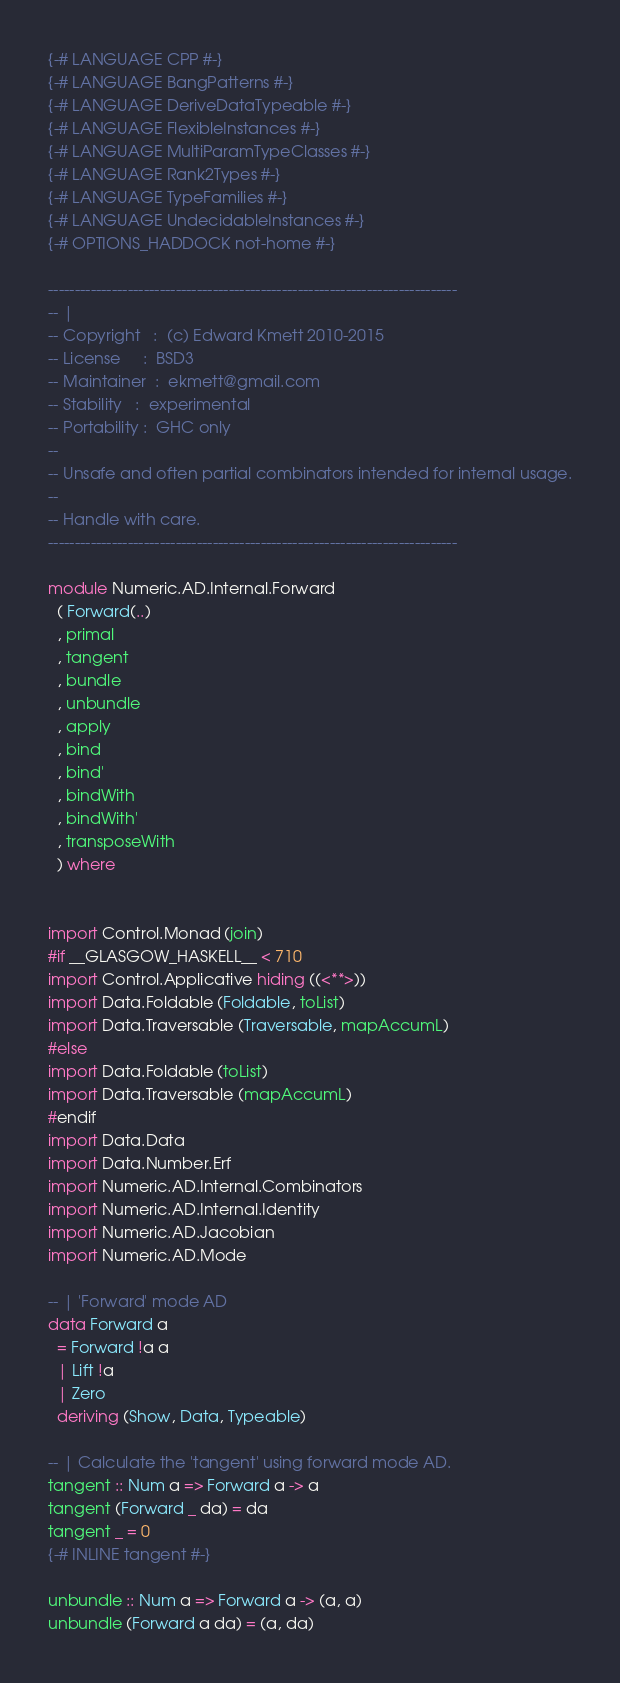<code> <loc_0><loc_0><loc_500><loc_500><_Haskell_>{-# LANGUAGE CPP #-}
{-# LANGUAGE BangPatterns #-}
{-# LANGUAGE DeriveDataTypeable #-}
{-# LANGUAGE FlexibleInstances #-}
{-# LANGUAGE MultiParamTypeClasses #-}
{-# LANGUAGE Rank2Types #-}
{-# LANGUAGE TypeFamilies #-}
{-# LANGUAGE UndecidableInstances #-}
{-# OPTIONS_HADDOCK not-home #-}

-----------------------------------------------------------------------------
-- |
-- Copyright   :  (c) Edward Kmett 2010-2015
-- License     :  BSD3
-- Maintainer  :  ekmett@gmail.com
-- Stability   :  experimental
-- Portability :  GHC only
--
-- Unsafe and often partial combinators intended for internal usage.
--
-- Handle with care.
-----------------------------------------------------------------------------

module Numeric.AD.Internal.Forward
  ( Forward(..)
  , primal
  , tangent
  , bundle
  , unbundle
  , apply
  , bind
  , bind'
  , bindWith
  , bindWith'
  , transposeWith
  ) where


import Control.Monad (join)
#if __GLASGOW_HASKELL__ < 710
import Control.Applicative hiding ((<**>))
import Data.Foldable (Foldable, toList)
import Data.Traversable (Traversable, mapAccumL)
#else
import Data.Foldable (toList)
import Data.Traversable (mapAccumL)
#endif
import Data.Data
import Data.Number.Erf
import Numeric.AD.Internal.Combinators
import Numeric.AD.Internal.Identity
import Numeric.AD.Jacobian
import Numeric.AD.Mode

-- | 'Forward' mode AD
data Forward a
  = Forward !a a
  | Lift !a
  | Zero
  deriving (Show, Data, Typeable)

-- | Calculate the 'tangent' using forward mode AD.
tangent :: Num a => Forward a -> a
tangent (Forward _ da) = da
tangent _ = 0
{-# INLINE tangent #-}

unbundle :: Num a => Forward a -> (a, a)
unbundle (Forward a da) = (a, da)</code> 